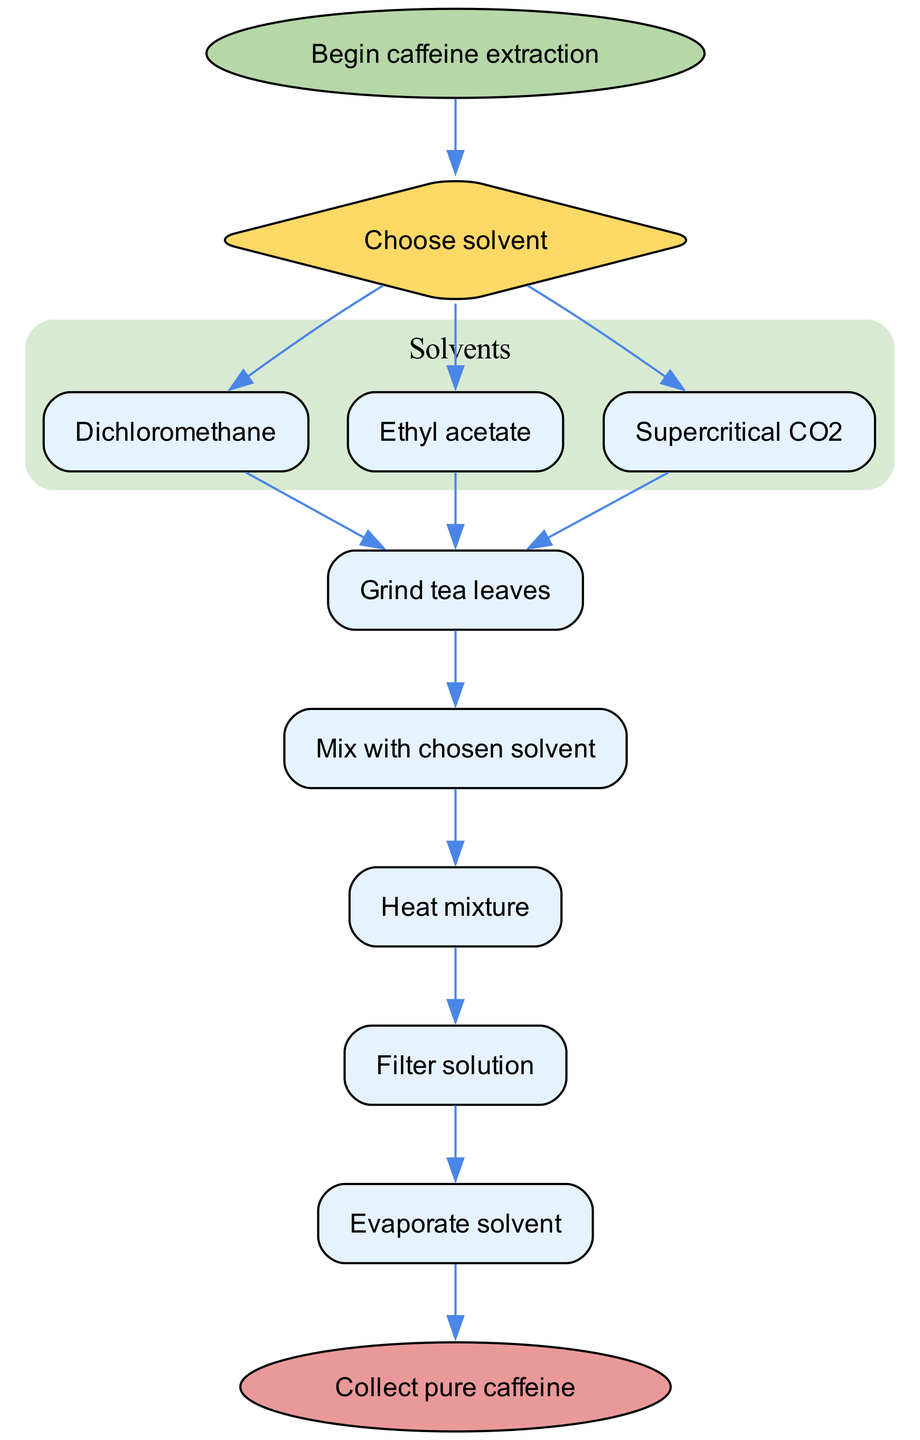What is the starting point of the extraction process? The flow chart indicates that the starting point is labeled as "Begin caffeine extraction"
Answer: Begin caffeine extraction How many solvents are listed in the diagram? The diagram lists three solvents: Dichloromethane, Ethyl acetate, and Supercritical CO2
Answer: 3 What is the second step after choosing a solvent? After the decision of which solvent to use, the second step is to "Mix with chosen solvent"
Answer: Mix with chosen solvent Which step follows the heating of the mixture? The step that follows "Heat mixture" is "Filter solution" in the extraction process
Answer: Filter solution How many steps are there in total after choosing a solvent? After making the solvent choice, there are a total of five steps detailed in the diagram
Answer: 5 What is the final outcome indicated in the diagram? The flow chart concludes with the final outcome, which is "Collect pure caffeine"
Answer: Collect pure caffeine In what order do you perform the steps after grinding the tea leaves? The order of steps after grinding is: Mix with chosen solvent, Heat mixture, Filter solution, Evaporate solvent
Answer: Mix with chosen solvent, Heat mixture, Filter solution, Evaporate solvent Which solvent is not part of the options given for extraction? The diagram does not include "Ethanol" as an option for solvents
Answer: Ethanol What shape is used for the decision node in the flow chart? The decision node in the flow chart is represented by a diamond shape
Answer: Diamond 